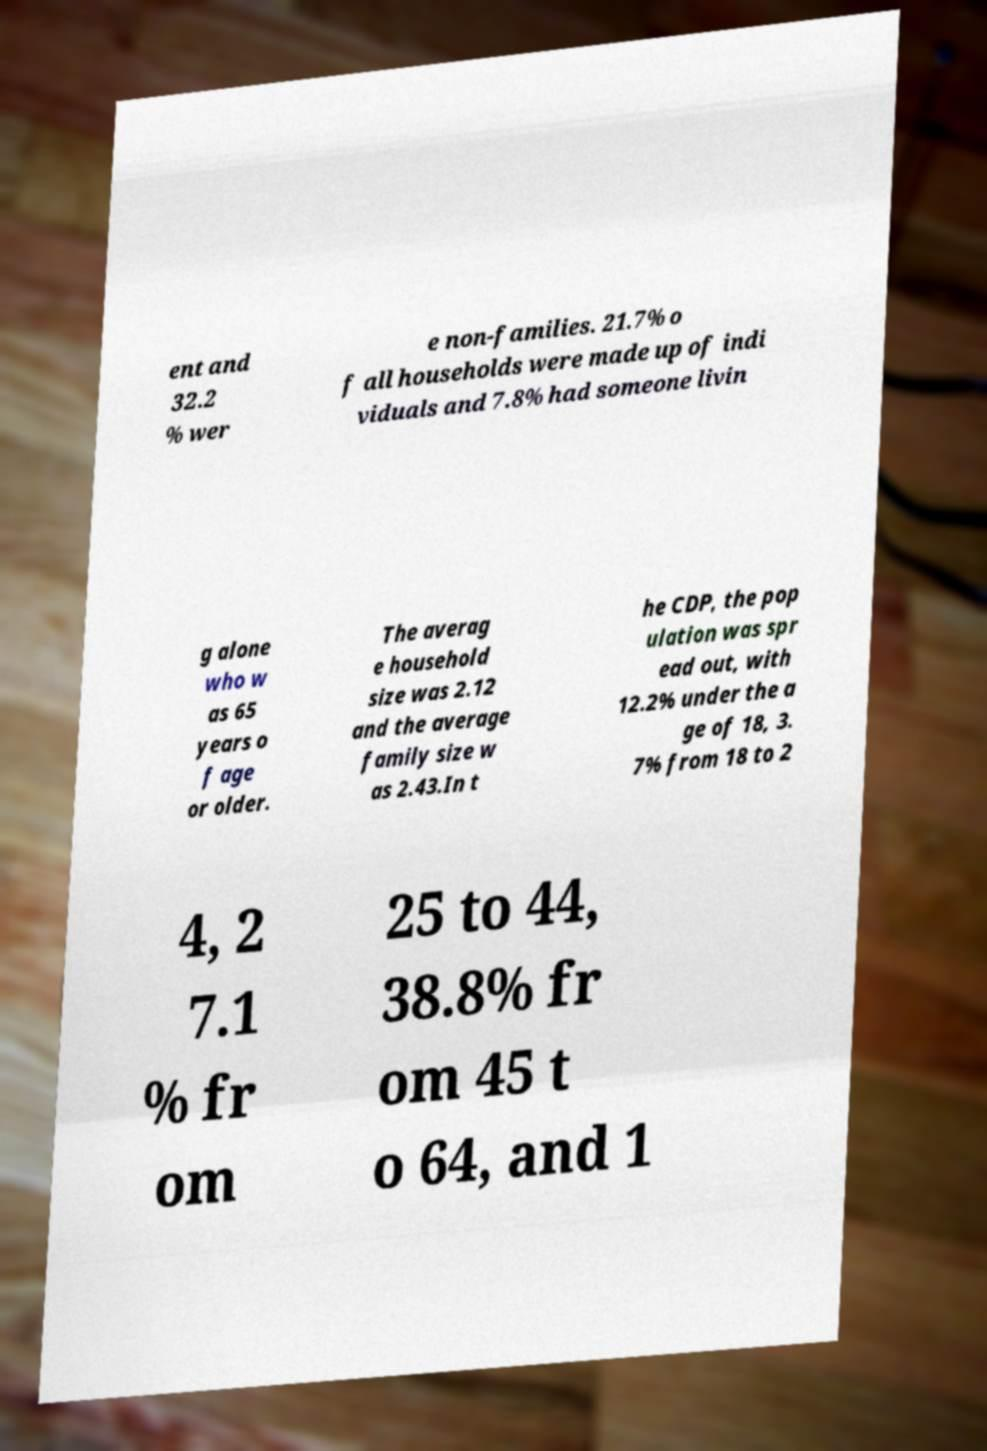I need the written content from this picture converted into text. Can you do that? ent and 32.2 % wer e non-families. 21.7% o f all households were made up of indi viduals and 7.8% had someone livin g alone who w as 65 years o f age or older. The averag e household size was 2.12 and the average family size w as 2.43.In t he CDP, the pop ulation was spr ead out, with 12.2% under the a ge of 18, 3. 7% from 18 to 2 4, 2 7.1 % fr om 25 to 44, 38.8% fr om 45 t o 64, and 1 